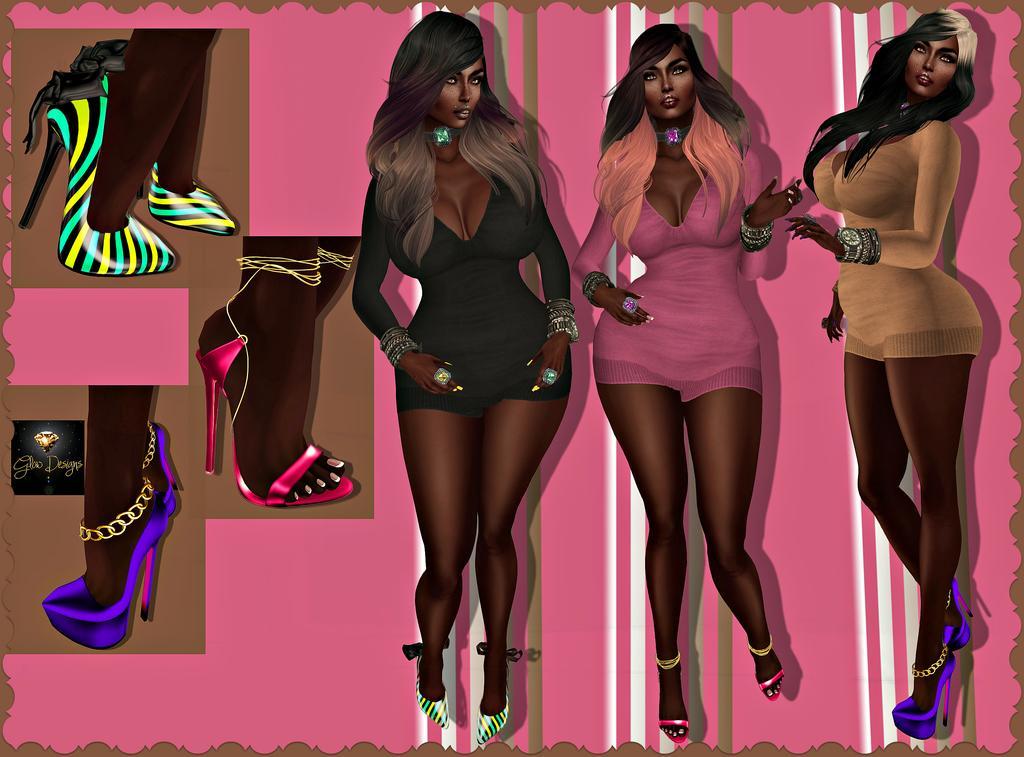How would you summarize this image in a sentence or two? In this image I can see depiction of women, clothes and sandals. I can also see pink colour in background. 